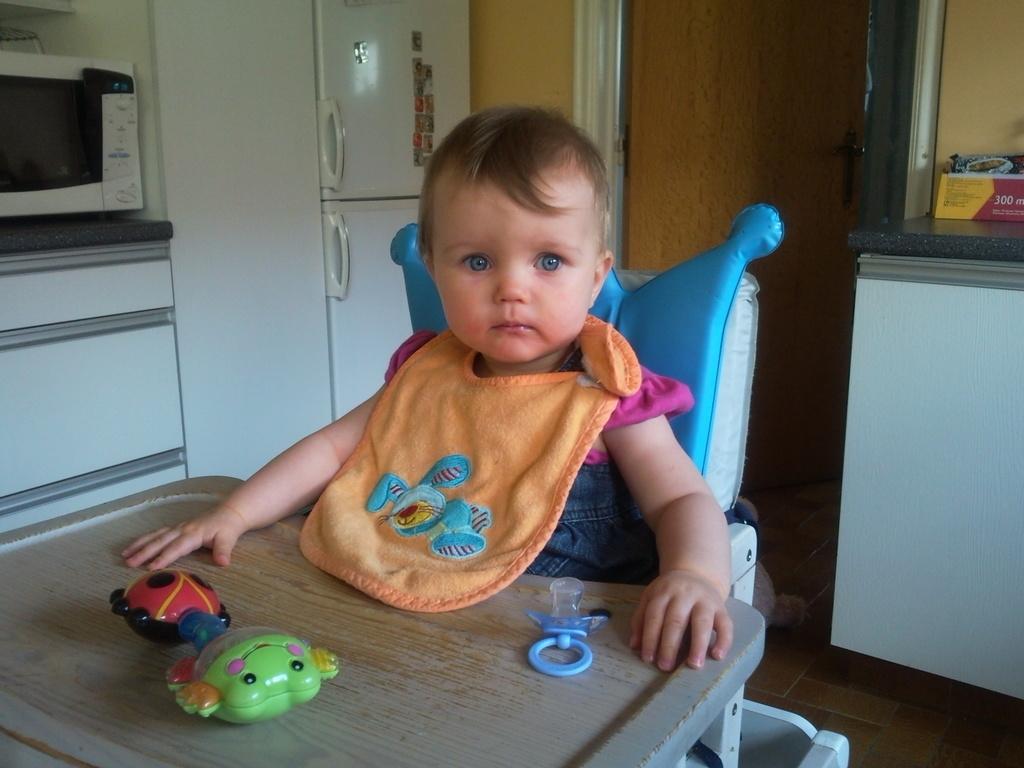Describe this image in one or two sentences. In this image we can see a child wearing a napkin sitting on a chair beside a table containing some toys on it. On the backside we can see an oven on a table, a refrigerator and a door. On the right side we can see some objects on a table and a wall. 